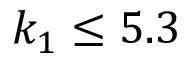Convert formula to latex. <formula><loc_0><loc_0><loc_500><loc_500>k _ { 1 } \leq 5 . 3</formula> 